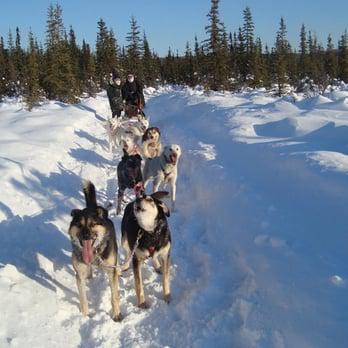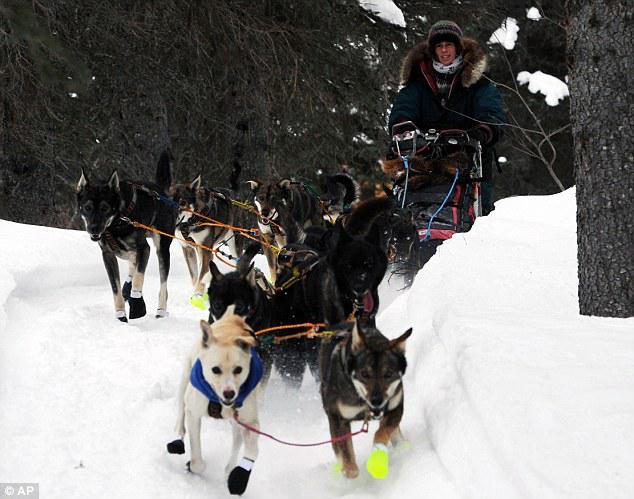The first image is the image on the left, the second image is the image on the right. Assess this claim about the two images: "There are at least two people riding on one of the dog sleds.". Correct or not? Answer yes or no. Yes. The first image is the image on the left, the second image is the image on the right. Analyze the images presented: Is the assertion "the right image has humans in red jackets" valid? Answer yes or no. No. 